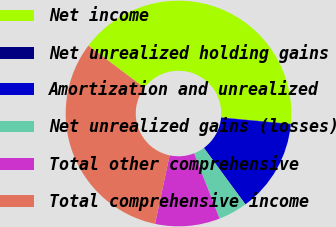Convert chart to OTSL. <chart><loc_0><loc_0><loc_500><loc_500><pie_chart><fcel>Net income<fcel>Net unrealized holding gains<fcel>Amortization and unrealized<fcel>Net unrealized gains (losses)<fcel>Total other comprehensive<fcel>Total comprehensive income<nl><fcel>41.2%<fcel>0.05%<fcel>13.38%<fcel>4.17%<fcel>9.26%<fcel>31.94%<nl></chart> 